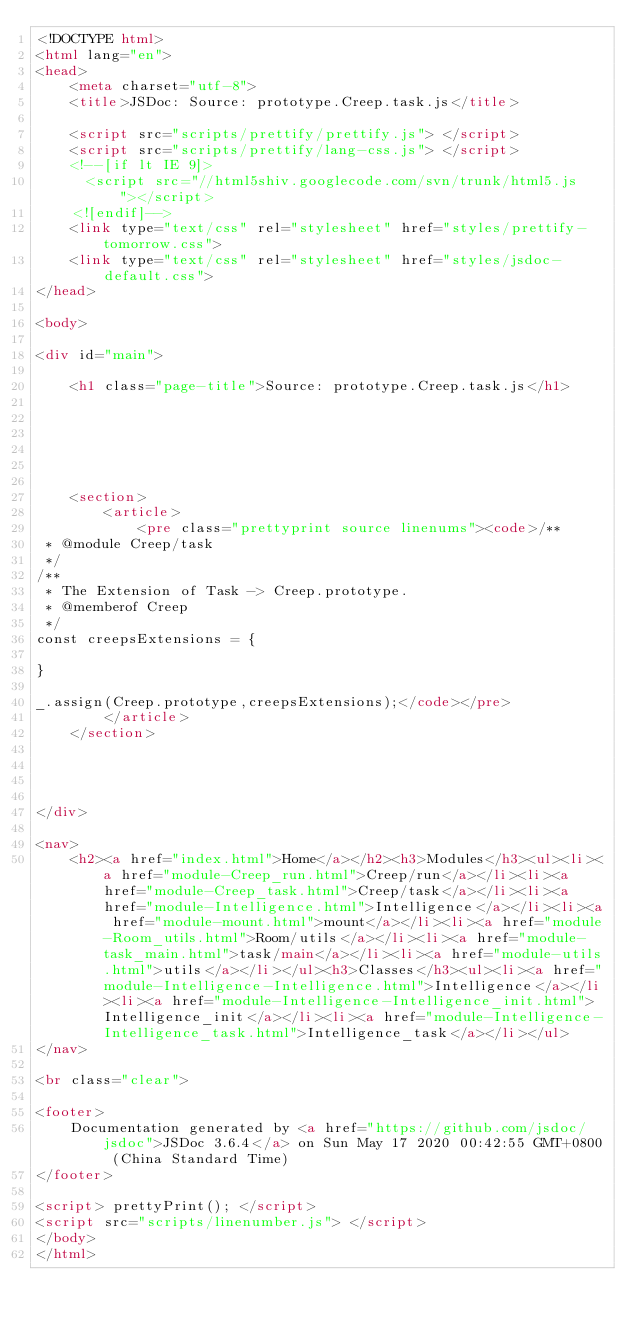<code> <loc_0><loc_0><loc_500><loc_500><_HTML_><!DOCTYPE html>
<html lang="en">
<head>
    <meta charset="utf-8">
    <title>JSDoc: Source: prototype.Creep.task.js</title>

    <script src="scripts/prettify/prettify.js"> </script>
    <script src="scripts/prettify/lang-css.js"> </script>
    <!--[if lt IE 9]>
      <script src="//html5shiv.googlecode.com/svn/trunk/html5.js"></script>
    <![endif]-->
    <link type="text/css" rel="stylesheet" href="styles/prettify-tomorrow.css">
    <link type="text/css" rel="stylesheet" href="styles/jsdoc-default.css">
</head>

<body>

<div id="main">

    <h1 class="page-title">Source: prototype.Creep.task.js</h1>

    



    
    <section>
        <article>
            <pre class="prettyprint source linenums"><code>/**
 * @module Creep/task
 */
/**
 * The Extension of Task -> Creep.prototype.
 * @memberof Creep
 */
const creepsExtensions = {

}

_.assign(Creep.prototype,creepsExtensions);</code></pre>
        </article>
    </section>




</div>

<nav>
    <h2><a href="index.html">Home</a></h2><h3>Modules</h3><ul><li><a href="module-Creep_run.html">Creep/run</a></li><li><a href="module-Creep_task.html">Creep/task</a></li><li><a href="module-Intelligence.html">Intelligence</a></li><li><a href="module-mount.html">mount</a></li><li><a href="module-Room_utils.html">Room/utils</a></li><li><a href="module-task_main.html">task/main</a></li><li><a href="module-utils.html">utils</a></li></ul><h3>Classes</h3><ul><li><a href="module-Intelligence-Intelligence.html">Intelligence</a></li><li><a href="module-Intelligence-Intelligence_init.html">Intelligence_init</a></li><li><a href="module-Intelligence-Intelligence_task.html">Intelligence_task</a></li></ul>
</nav>

<br class="clear">

<footer>
    Documentation generated by <a href="https://github.com/jsdoc/jsdoc">JSDoc 3.6.4</a> on Sun May 17 2020 00:42:55 GMT+0800 (China Standard Time)
</footer>

<script> prettyPrint(); </script>
<script src="scripts/linenumber.js"> </script>
</body>
</html>
</code> 